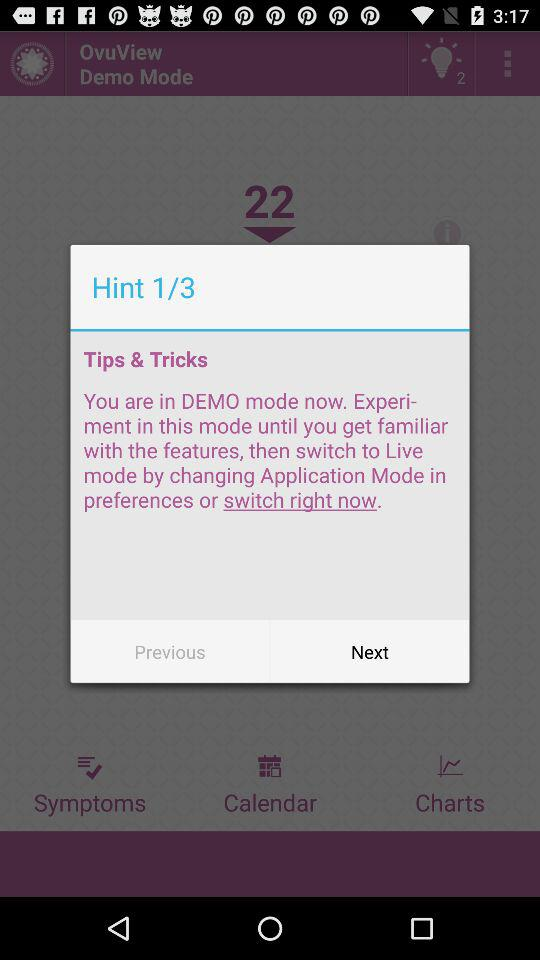Which mode is shown currently? The mode shown currently is demo. 